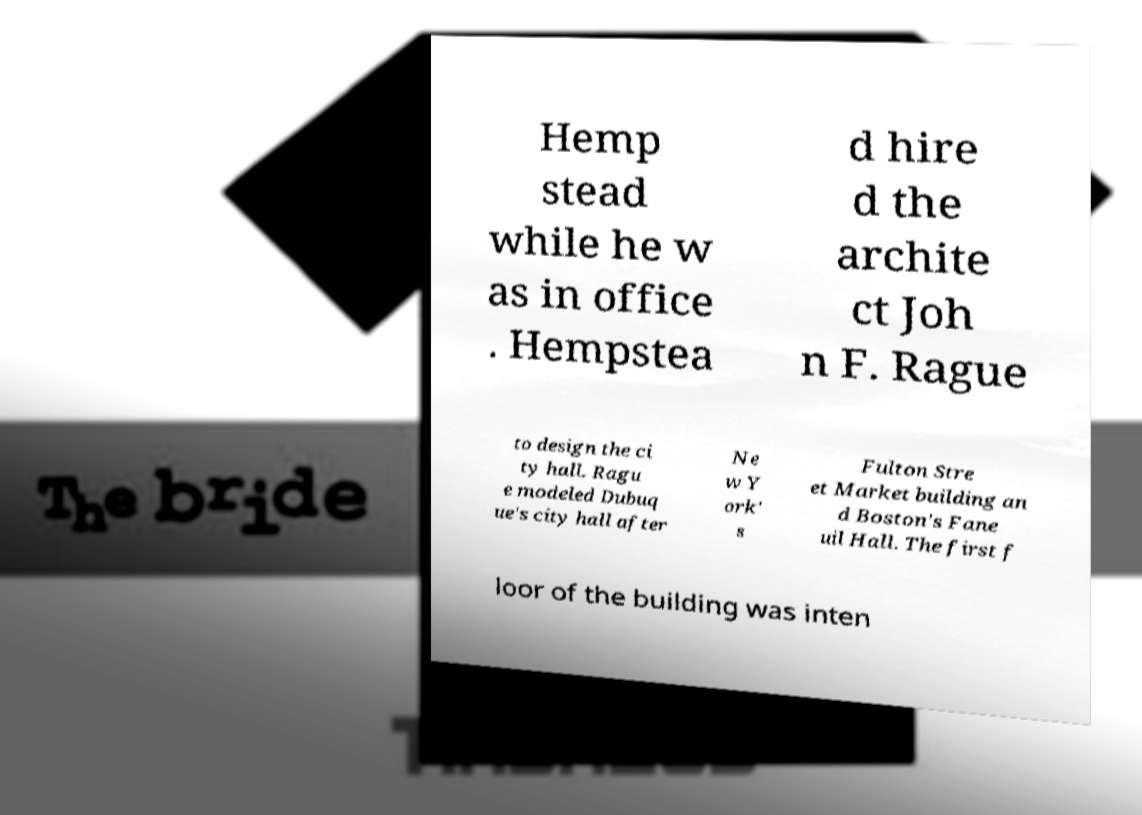There's text embedded in this image that I need extracted. Can you transcribe it verbatim? Hemp stead while he w as in office . Hempstea d hire d the archite ct Joh n F. Rague to design the ci ty hall. Ragu e modeled Dubuq ue's city hall after Ne w Y ork' s Fulton Stre et Market building an d Boston's Fane uil Hall. The first f loor of the building was inten 